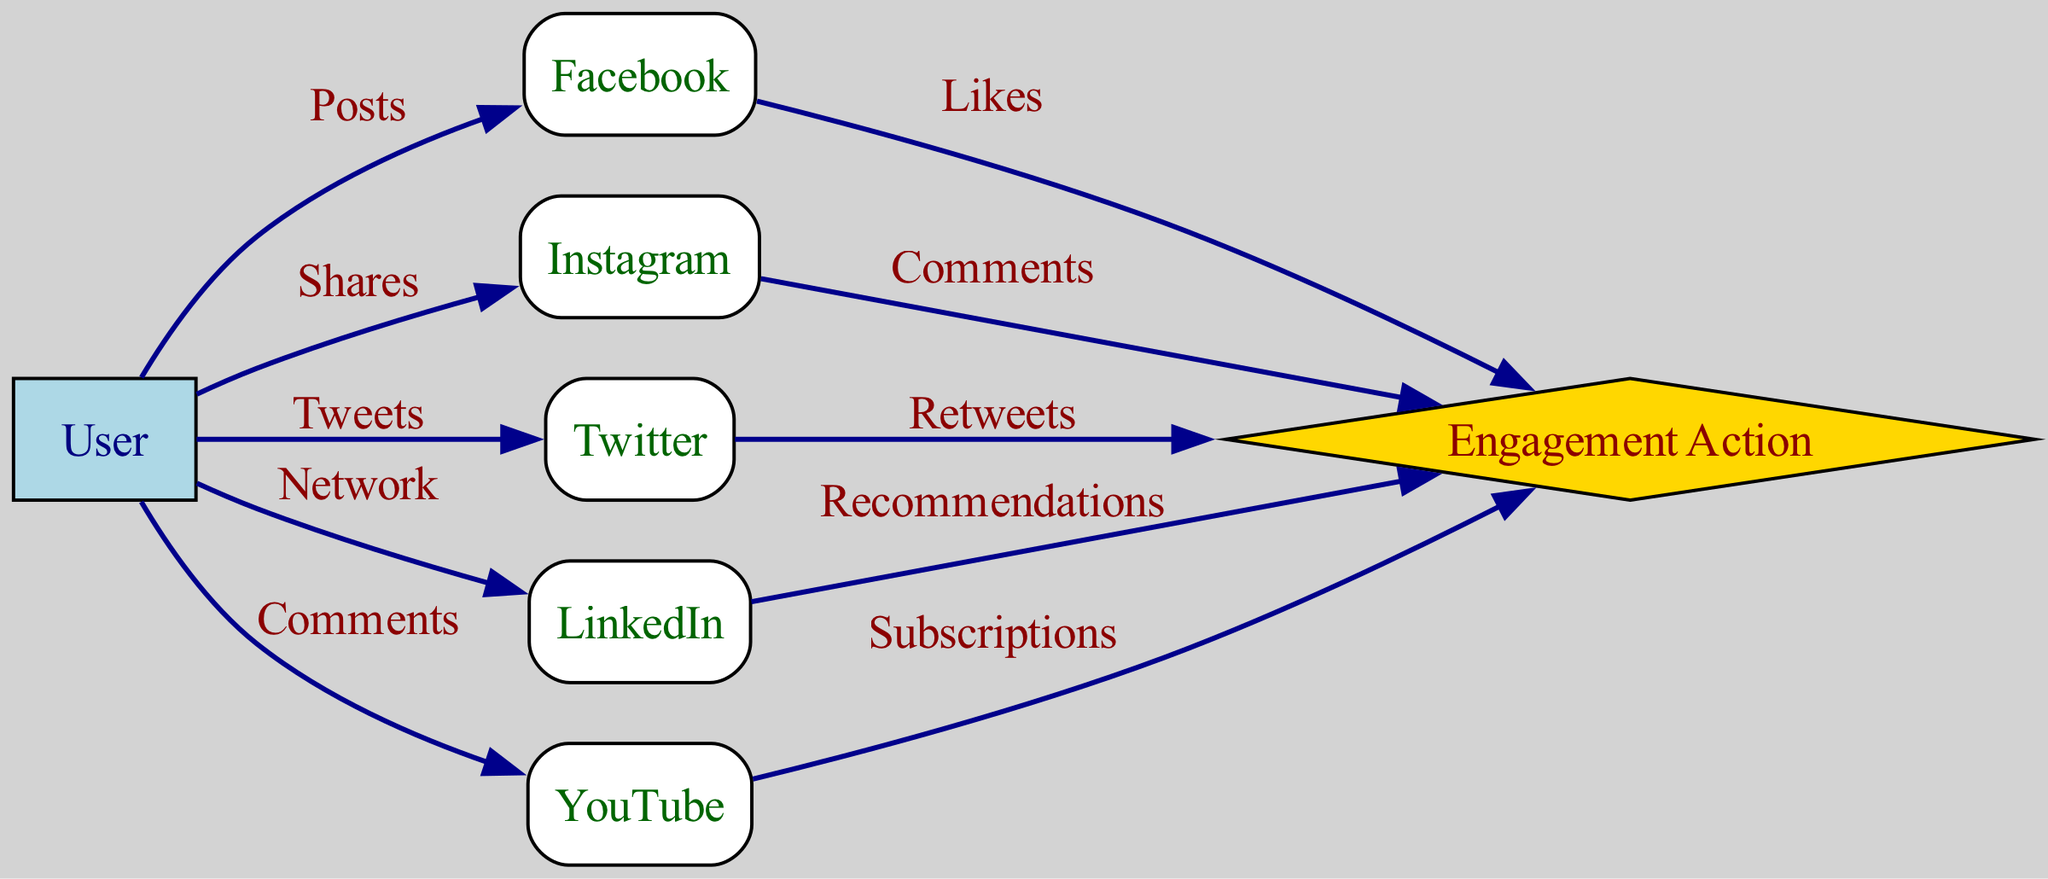What is the total number of nodes in the diagram? By counting the nodes listed in the given data, we have User, Facebook, Instagram, Twitter, LinkedIn, YouTube, and Engagement. This gives us a total of 7 nodes.
Answer: 7 What type of engagement is associated with Facebook? The edge between Facebook and Engagement shows the label "Likes," indicating that the engagement action associated with Facebook is Likes.
Answer: Likes Which platform does the user interact with by tweeting? The edge shows that the User connects to Twitter with the label "Tweets," which indicates that the interactive action performed by the user is associated with Twitter.
Answer: Twitter How many engagement actions are linked to user interactions? Each social media platform has one engagement action listed in the edges: Likes for Facebook, Comments for Instagram, Retweets for Twitter, Recommendations for LinkedIn, and Subscriptions for YouTube. This sums up to 5 engagement actions.
Answer: 5 Which two platforms have the most direct user interactions? Analyzing the edges, we can see that the User has direct interactions with all listed platforms (Facebook, Instagram, Twitter, LinkedIn, and YouTube), and all these connections directly originate from the User node. However, there are no intersections or overlaps of actions between platforms, so all have equal direct engagement.
Answer: All platforms equal What is the relationship between Instagram and Engagement? The edge from Instagram to Engagement is labeled "Comments," meaning that the relationship is that users can engage with Instagram content through Comments.
Answer: Comments Which platform does not lead to engagement directly? The User node connects directly to all platforms; however, the User node itself does not have an engagement action directed from it; rather, all actions flow from the individual platforms to Engagement. Therefore, the User itself does not lead to engagement directly.
Answer: User Which platform is indicated as having the action 'Subscriptions'? The edge from YouTube to Engagement is labeled "Subscriptions," indicating that the engagement action related to YouTube is Subscriptions.
Answer: YouTube 